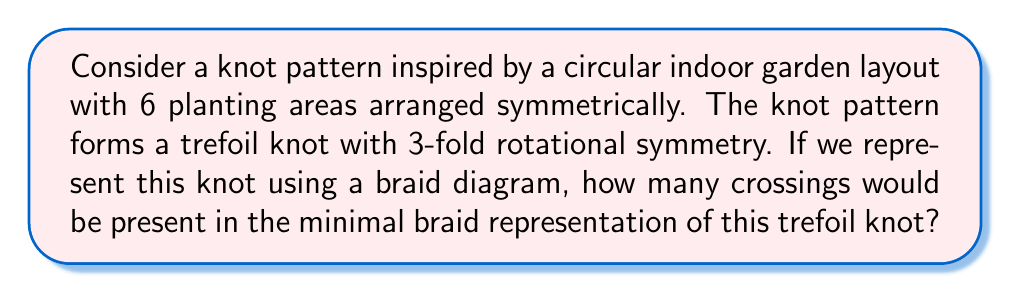Can you answer this question? To solve this problem, let's follow these steps:

1. Understand the trefoil knot:
   The trefoil knot is the simplest non-trivial knot, with a crossing number of 3.

2. Analyze the symmetry:
   The knot has 3-fold rotational symmetry, which matches the symmetry of the trefoil knot.

3. Braid representation:
   A braid representation of a knot is a way to depict the knot as a set of intertwined strands.

4. Minimal braid representation:
   The minimal braid representation is the one with the fewest number of crossings that still accurately represents the knot.

5. Trefoil knot braid representation:
   The minimal braid representation of a trefoil knot can be written in braid notation as $\sigma_1^3$ or $\sigma_1\sigma_1\sigma_1$, where $\sigma_1$ represents a positive crossing of adjacent strands.

6. Count the crossings:
   In the minimal braid representation $\sigma_1^3$, there are 3 crossings.

[asy]
import geometry;

size(100);
pair A = (0,0), B = (1,0), C = (0.5, 0.866);
draw(A--B--C--cycle);
draw(circle(A, 0.1));
draw(circle(B, 0.1));
draw(circle(C, 0.1));

pair D = (0.5, 0.289);
draw(D+(0.2,0)--D+(-0.2,0), arrow=Arrow(TeXHead));
draw(D+(0,0.2)--D+(0,-0.2), arrow=Arrow(TeXHead));
draw(D+(-0.173,0.1)--D+(0.173,-0.1), arrow=Arrow(TeXHead));
[/asy]

The diagram above shows a schematic representation of the trefoil knot with its 3-fold rotational symmetry, which corresponds to the minimal braid representation with 3 crossings.
Answer: 3 crossings 